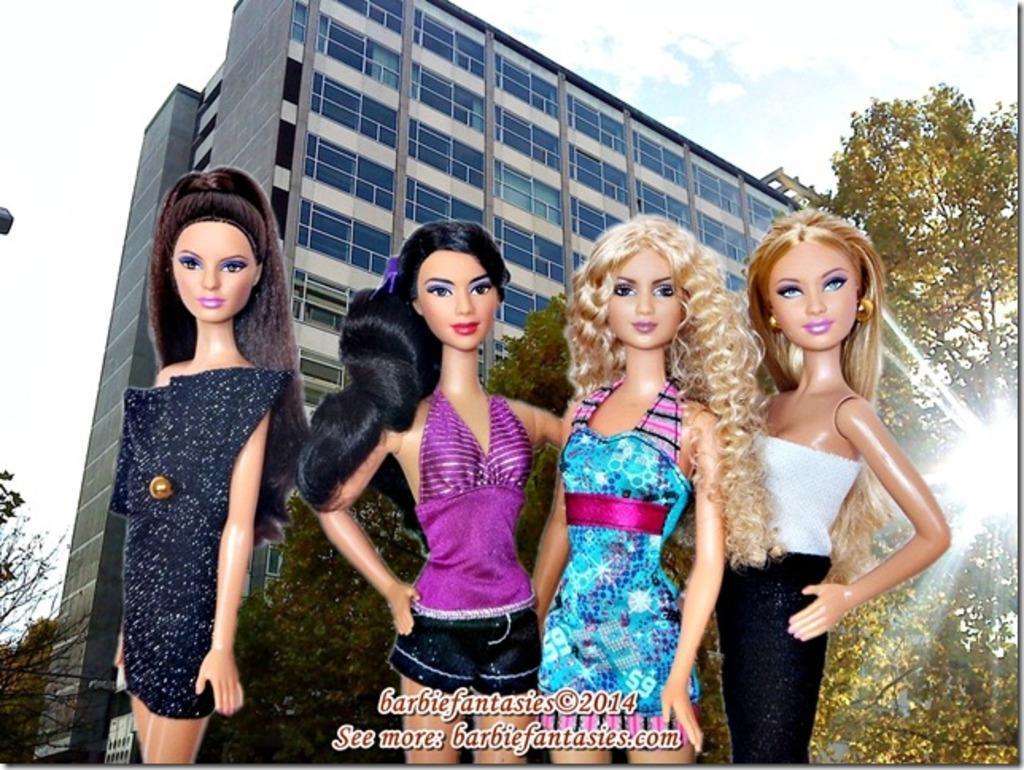Describe this image in one or two sentences. In this image we can see some cartoon images, there is a building, windows, trees, also we can see the sky, and there are some text on the image. 